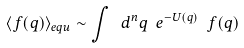Convert formula to latex. <formula><loc_0><loc_0><loc_500><loc_500>\langle f ( q ) \rangle _ { e q u } \sim \int \ d ^ { n } q \ e ^ { - U ( q ) } \ f ( q )</formula> 